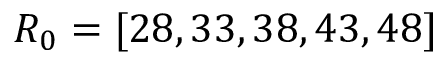Convert formula to latex. <formula><loc_0><loc_0><loc_500><loc_500>{ R _ { 0 } } = [ 2 8 , 3 3 , 3 8 , 4 3 , 4 8 ]</formula> 